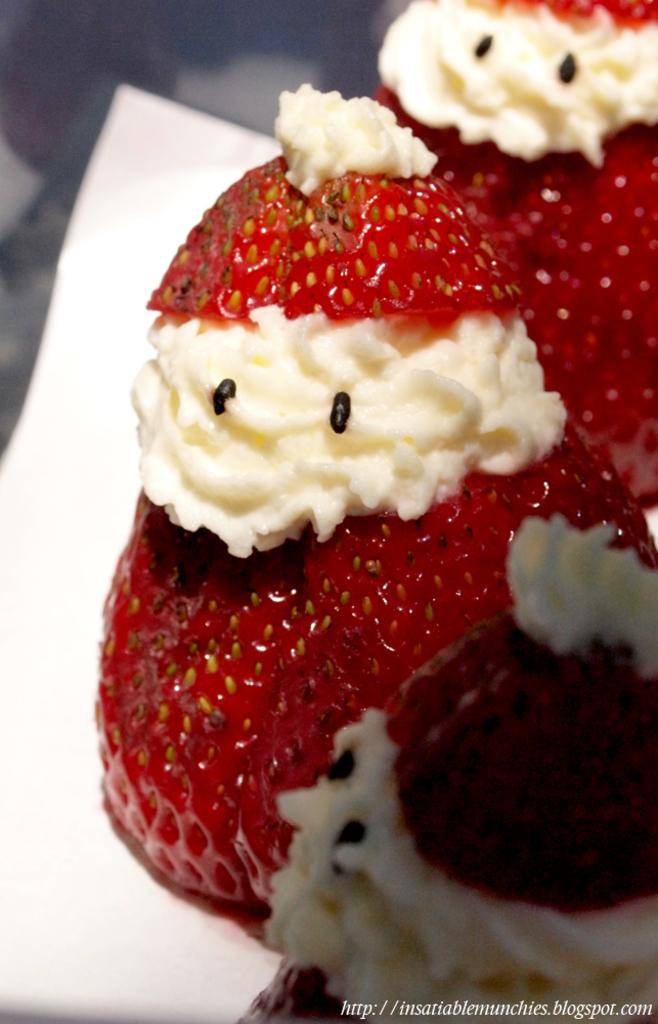What type of fruit is paired with cream in the image? There are strawberries with cream on the right side of the image. What color is the surface on which the strawberries and cream are placed? The surface is white. Where is the link located in the image? The link is in the bottom right corner of the image. What type of interest is being paid on the strawberries in the image? There is no mention of interest or financial transactions in the image; it features strawberries with cream on a white surface. 